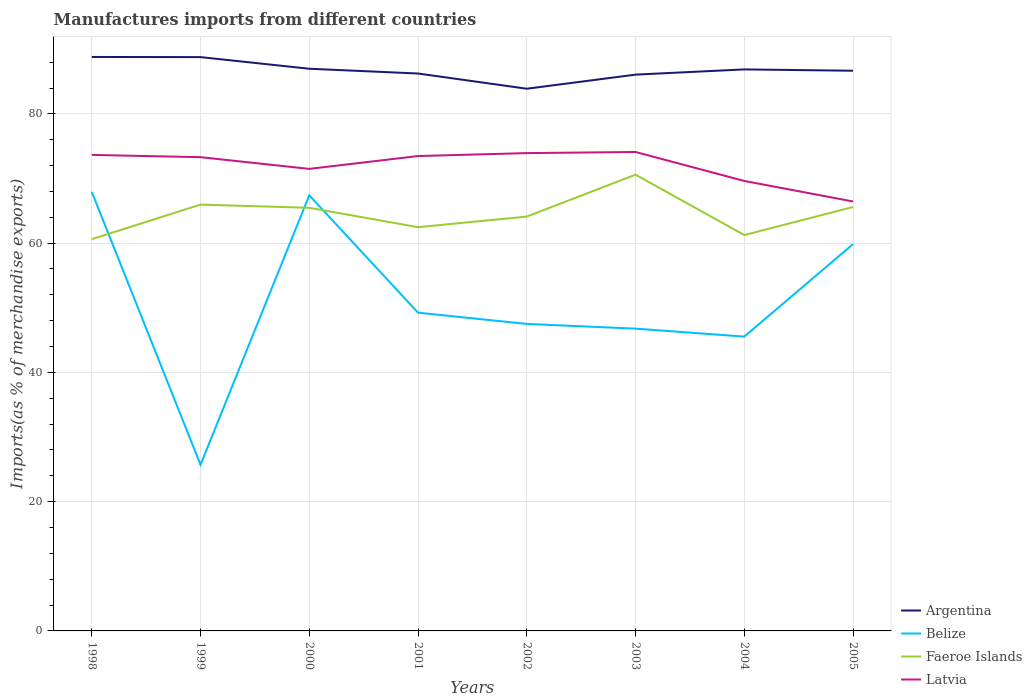How many different coloured lines are there?
Your answer should be very brief. 4. Does the line corresponding to Argentina intersect with the line corresponding to Faeroe Islands?
Your answer should be compact. No. Across all years, what is the maximum percentage of imports to different countries in Belize?
Offer a very short reply. 25.71. What is the total percentage of imports to different countries in Argentina in the graph?
Ensure brevity in your answer.  0.21. What is the difference between the highest and the second highest percentage of imports to different countries in Argentina?
Give a very brief answer. 4.91. What is the difference between the highest and the lowest percentage of imports to different countries in Faeroe Islands?
Your answer should be compact. 4. Is the percentage of imports to different countries in Faeroe Islands strictly greater than the percentage of imports to different countries in Belize over the years?
Your answer should be very brief. No. Does the graph contain any zero values?
Your answer should be very brief. No. Does the graph contain grids?
Make the answer very short. Yes. Where does the legend appear in the graph?
Provide a succinct answer. Bottom right. How many legend labels are there?
Keep it short and to the point. 4. What is the title of the graph?
Make the answer very short. Manufactures imports from different countries. What is the label or title of the X-axis?
Provide a succinct answer. Years. What is the label or title of the Y-axis?
Give a very brief answer. Imports(as % of merchandise exports). What is the Imports(as % of merchandise exports) in Argentina in 1998?
Keep it short and to the point. 88.81. What is the Imports(as % of merchandise exports) in Belize in 1998?
Offer a very short reply. 67.93. What is the Imports(as % of merchandise exports) of Faeroe Islands in 1998?
Your answer should be very brief. 60.61. What is the Imports(as % of merchandise exports) in Latvia in 1998?
Your answer should be compact. 73.65. What is the Imports(as % of merchandise exports) of Argentina in 1999?
Offer a terse response. 88.78. What is the Imports(as % of merchandise exports) of Belize in 1999?
Give a very brief answer. 25.71. What is the Imports(as % of merchandise exports) in Faeroe Islands in 1999?
Your answer should be very brief. 65.96. What is the Imports(as % of merchandise exports) of Latvia in 1999?
Make the answer very short. 73.3. What is the Imports(as % of merchandise exports) in Argentina in 2000?
Give a very brief answer. 86.98. What is the Imports(as % of merchandise exports) of Belize in 2000?
Keep it short and to the point. 67.4. What is the Imports(as % of merchandise exports) of Faeroe Islands in 2000?
Give a very brief answer. 65.47. What is the Imports(as % of merchandise exports) of Latvia in 2000?
Provide a short and direct response. 71.49. What is the Imports(as % of merchandise exports) in Argentina in 2001?
Offer a very short reply. 86.25. What is the Imports(as % of merchandise exports) in Belize in 2001?
Your response must be concise. 49.24. What is the Imports(as % of merchandise exports) in Faeroe Islands in 2001?
Your answer should be compact. 62.47. What is the Imports(as % of merchandise exports) of Latvia in 2001?
Your answer should be compact. 73.48. What is the Imports(as % of merchandise exports) of Argentina in 2002?
Your response must be concise. 83.89. What is the Imports(as % of merchandise exports) of Belize in 2002?
Ensure brevity in your answer.  47.5. What is the Imports(as % of merchandise exports) of Faeroe Islands in 2002?
Make the answer very short. 64.11. What is the Imports(as % of merchandise exports) of Latvia in 2002?
Provide a short and direct response. 73.93. What is the Imports(as % of merchandise exports) in Argentina in 2003?
Your answer should be very brief. 86.07. What is the Imports(as % of merchandise exports) in Belize in 2003?
Offer a very short reply. 46.77. What is the Imports(as % of merchandise exports) in Faeroe Islands in 2003?
Provide a succinct answer. 70.6. What is the Imports(as % of merchandise exports) in Latvia in 2003?
Offer a very short reply. 74.1. What is the Imports(as % of merchandise exports) of Argentina in 2004?
Provide a succinct answer. 86.88. What is the Imports(as % of merchandise exports) in Belize in 2004?
Make the answer very short. 45.54. What is the Imports(as % of merchandise exports) in Faeroe Islands in 2004?
Keep it short and to the point. 61.25. What is the Imports(as % of merchandise exports) in Latvia in 2004?
Offer a terse response. 69.62. What is the Imports(as % of merchandise exports) in Argentina in 2005?
Ensure brevity in your answer.  86.68. What is the Imports(as % of merchandise exports) of Belize in 2005?
Ensure brevity in your answer.  59.85. What is the Imports(as % of merchandise exports) of Faeroe Islands in 2005?
Ensure brevity in your answer.  65.59. What is the Imports(as % of merchandise exports) of Latvia in 2005?
Your answer should be compact. 66.45. Across all years, what is the maximum Imports(as % of merchandise exports) of Argentina?
Give a very brief answer. 88.81. Across all years, what is the maximum Imports(as % of merchandise exports) in Belize?
Make the answer very short. 67.93. Across all years, what is the maximum Imports(as % of merchandise exports) in Faeroe Islands?
Offer a very short reply. 70.6. Across all years, what is the maximum Imports(as % of merchandise exports) of Latvia?
Offer a very short reply. 74.1. Across all years, what is the minimum Imports(as % of merchandise exports) in Argentina?
Provide a succinct answer. 83.89. Across all years, what is the minimum Imports(as % of merchandise exports) in Belize?
Give a very brief answer. 25.71. Across all years, what is the minimum Imports(as % of merchandise exports) of Faeroe Islands?
Your response must be concise. 60.61. Across all years, what is the minimum Imports(as % of merchandise exports) of Latvia?
Give a very brief answer. 66.45. What is the total Imports(as % of merchandise exports) of Argentina in the graph?
Provide a succinct answer. 694.34. What is the total Imports(as % of merchandise exports) of Belize in the graph?
Ensure brevity in your answer.  409.94. What is the total Imports(as % of merchandise exports) in Faeroe Islands in the graph?
Offer a very short reply. 516.06. What is the total Imports(as % of merchandise exports) in Latvia in the graph?
Keep it short and to the point. 576.02. What is the difference between the Imports(as % of merchandise exports) of Argentina in 1998 and that in 1999?
Make the answer very short. 0.02. What is the difference between the Imports(as % of merchandise exports) of Belize in 1998 and that in 1999?
Your answer should be very brief. 42.21. What is the difference between the Imports(as % of merchandise exports) in Faeroe Islands in 1998 and that in 1999?
Offer a very short reply. -5.35. What is the difference between the Imports(as % of merchandise exports) in Latvia in 1998 and that in 1999?
Provide a short and direct response. 0.35. What is the difference between the Imports(as % of merchandise exports) in Argentina in 1998 and that in 2000?
Give a very brief answer. 1.82. What is the difference between the Imports(as % of merchandise exports) in Belize in 1998 and that in 2000?
Keep it short and to the point. 0.52. What is the difference between the Imports(as % of merchandise exports) of Faeroe Islands in 1998 and that in 2000?
Offer a very short reply. -4.86. What is the difference between the Imports(as % of merchandise exports) in Latvia in 1998 and that in 2000?
Give a very brief answer. 2.16. What is the difference between the Imports(as % of merchandise exports) in Argentina in 1998 and that in 2001?
Your answer should be very brief. 2.56. What is the difference between the Imports(as % of merchandise exports) in Belize in 1998 and that in 2001?
Your answer should be compact. 18.68. What is the difference between the Imports(as % of merchandise exports) of Faeroe Islands in 1998 and that in 2001?
Your response must be concise. -1.86. What is the difference between the Imports(as % of merchandise exports) in Latvia in 1998 and that in 2001?
Provide a succinct answer. 0.18. What is the difference between the Imports(as % of merchandise exports) of Argentina in 1998 and that in 2002?
Offer a very short reply. 4.91. What is the difference between the Imports(as % of merchandise exports) of Belize in 1998 and that in 2002?
Keep it short and to the point. 20.43. What is the difference between the Imports(as % of merchandise exports) in Faeroe Islands in 1998 and that in 2002?
Offer a very short reply. -3.5. What is the difference between the Imports(as % of merchandise exports) in Latvia in 1998 and that in 2002?
Your answer should be compact. -0.28. What is the difference between the Imports(as % of merchandise exports) in Argentina in 1998 and that in 2003?
Ensure brevity in your answer.  2.73. What is the difference between the Imports(as % of merchandise exports) of Belize in 1998 and that in 2003?
Keep it short and to the point. 21.16. What is the difference between the Imports(as % of merchandise exports) of Faeroe Islands in 1998 and that in 2003?
Your response must be concise. -9.98. What is the difference between the Imports(as % of merchandise exports) of Latvia in 1998 and that in 2003?
Make the answer very short. -0.45. What is the difference between the Imports(as % of merchandise exports) in Argentina in 1998 and that in 2004?
Offer a very short reply. 1.93. What is the difference between the Imports(as % of merchandise exports) of Belize in 1998 and that in 2004?
Offer a very short reply. 22.39. What is the difference between the Imports(as % of merchandise exports) in Faeroe Islands in 1998 and that in 2004?
Your response must be concise. -0.64. What is the difference between the Imports(as % of merchandise exports) of Latvia in 1998 and that in 2004?
Your answer should be very brief. 4.03. What is the difference between the Imports(as % of merchandise exports) of Argentina in 1998 and that in 2005?
Your answer should be compact. 2.13. What is the difference between the Imports(as % of merchandise exports) in Belize in 1998 and that in 2005?
Your response must be concise. 8.08. What is the difference between the Imports(as % of merchandise exports) in Faeroe Islands in 1998 and that in 2005?
Your answer should be compact. -4.98. What is the difference between the Imports(as % of merchandise exports) of Latvia in 1998 and that in 2005?
Make the answer very short. 7.21. What is the difference between the Imports(as % of merchandise exports) of Argentina in 1999 and that in 2000?
Offer a terse response. 1.8. What is the difference between the Imports(as % of merchandise exports) of Belize in 1999 and that in 2000?
Offer a terse response. -41.69. What is the difference between the Imports(as % of merchandise exports) in Faeroe Islands in 1999 and that in 2000?
Make the answer very short. 0.49. What is the difference between the Imports(as % of merchandise exports) in Latvia in 1999 and that in 2000?
Provide a succinct answer. 1.81. What is the difference between the Imports(as % of merchandise exports) in Argentina in 1999 and that in 2001?
Your response must be concise. 2.54. What is the difference between the Imports(as % of merchandise exports) of Belize in 1999 and that in 2001?
Your response must be concise. -23.53. What is the difference between the Imports(as % of merchandise exports) of Faeroe Islands in 1999 and that in 2001?
Provide a short and direct response. 3.49. What is the difference between the Imports(as % of merchandise exports) of Latvia in 1999 and that in 2001?
Offer a very short reply. -0.17. What is the difference between the Imports(as % of merchandise exports) in Argentina in 1999 and that in 2002?
Your answer should be compact. 4.89. What is the difference between the Imports(as % of merchandise exports) of Belize in 1999 and that in 2002?
Offer a terse response. -21.79. What is the difference between the Imports(as % of merchandise exports) in Faeroe Islands in 1999 and that in 2002?
Your answer should be very brief. 1.85. What is the difference between the Imports(as % of merchandise exports) of Latvia in 1999 and that in 2002?
Offer a very short reply. -0.63. What is the difference between the Imports(as % of merchandise exports) in Argentina in 1999 and that in 2003?
Provide a short and direct response. 2.71. What is the difference between the Imports(as % of merchandise exports) of Belize in 1999 and that in 2003?
Your answer should be compact. -21.06. What is the difference between the Imports(as % of merchandise exports) in Faeroe Islands in 1999 and that in 2003?
Ensure brevity in your answer.  -4.63. What is the difference between the Imports(as % of merchandise exports) in Latvia in 1999 and that in 2003?
Provide a short and direct response. -0.8. What is the difference between the Imports(as % of merchandise exports) of Argentina in 1999 and that in 2004?
Keep it short and to the point. 1.9. What is the difference between the Imports(as % of merchandise exports) in Belize in 1999 and that in 2004?
Ensure brevity in your answer.  -19.83. What is the difference between the Imports(as % of merchandise exports) of Faeroe Islands in 1999 and that in 2004?
Provide a short and direct response. 4.71. What is the difference between the Imports(as % of merchandise exports) of Latvia in 1999 and that in 2004?
Provide a short and direct response. 3.68. What is the difference between the Imports(as % of merchandise exports) in Argentina in 1999 and that in 2005?
Keep it short and to the point. 2.11. What is the difference between the Imports(as % of merchandise exports) of Belize in 1999 and that in 2005?
Your answer should be very brief. -34.13. What is the difference between the Imports(as % of merchandise exports) of Faeroe Islands in 1999 and that in 2005?
Make the answer very short. 0.37. What is the difference between the Imports(as % of merchandise exports) in Latvia in 1999 and that in 2005?
Your answer should be very brief. 6.86. What is the difference between the Imports(as % of merchandise exports) of Argentina in 2000 and that in 2001?
Keep it short and to the point. 0.74. What is the difference between the Imports(as % of merchandise exports) in Belize in 2000 and that in 2001?
Make the answer very short. 18.16. What is the difference between the Imports(as % of merchandise exports) of Faeroe Islands in 2000 and that in 2001?
Provide a short and direct response. 3. What is the difference between the Imports(as % of merchandise exports) of Latvia in 2000 and that in 2001?
Provide a succinct answer. -1.99. What is the difference between the Imports(as % of merchandise exports) of Argentina in 2000 and that in 2002?
Your answer should be very brief. 3.09. What is the difference between the Imports(as % of merchandise exports) in Belize in 2000 and that in 2002?
Your answer should be very brief. 19.9. What is the difference between the Imports(as % of merchandise exports) in Faeroe Islands in 2000 and that in 2002?
Make the answer very short. 1.36. What is the difference between the Imports(as % of merchandise exports) in Latvia in 2000 and that in 2002?
Offer a very short reply. -2.44. What is the difference between the Imports(as % of merchandise exports) in Argentina in 2000 and that in 2003?
Make the answer very short. 0.91. What is the difference between the Imports(as % of merchandise exports) of Belize in 2000 and that in 2003?
Your answer should be compact. 20.63. What is the difference between the Imports(as % of merchandise exports) in Faeroe Islands in 2000 and that in 2003?
Your response must be concise. -5.13. What is the difference between the Imports(as % of merchandise exports) in Latvia in 2000 and that in 2003?
Your answer should be compact. -2.61. What is the difference between the Imports(as % of merchandise exports) in Argentina in 2000 and that in 2004?
Your answer should be very brief. 0.1. What is the difference between the Imports(as % of merchandise exports) of Belize in 2000 and that in 2004?
Make the answer very short. 21.86. What is the difference between the Imports(as % of merchandise exports) of Faeroe Islands in 2000 and that in 2004?
Your answer should be very brief. 4.22. What is the difference between the Imports(as % of merchandise exports) in Latvia in 2000 and that in 2004?
Your answer should be very brief. 1.87. What is the difference between the Imports(as % of merchandise exports) in Argentina in 2000 and that in 2005?
Your answer should be very brief. 0.31. What is the difference between the Imports(as % of merchandise exports) in Belize in 2000 and that in 2005?
Keep it short and to the point. 7.56. What is the difference between the Imports(as % of merchandise exports) of Faeroe Islands in 2000 and that in 2005?
Make the answer very short. -0.12. What is the difference between the Imports(as % of merchandise exports) in Latvia in 2000 and that in 2005?
Offer a terse response. 5.04. What is the difference between the Imports(as % of merchandise exports) of Argentina in 2001 and that in 2002?
Your answer should be compact. 2.35. What is the difference between the Imports(as % of merchandise exports) of Belize in 2001 and that in 2002?
Your response must be concise. 1.74. What is the difference between the Imports(as % of merchandise exports) in Faeroe Islands in 2001 and that in 2002?
Offer a very short reply. -1.64. What is the difference between the Imports(as % of merchandise exports) in Latvia in 2001 and that in 2002?
Give a very brief answer. -0.46. What is the difference between the Imports(as % of merchandise exports) of Argentina in 2001 and that in 2003?
Your response must be concise. 0.17. What is the difference between the Imports(as % of merchandise exports) in Belize in 2001 and that in 2003?
Provide a succinct answer. 2.47. What is the difference between the Imports(as % of merchandise exports) in Faeroe Islands in 2001 and that in 2003?
Your response must be concise. -8.13. What is the difference between the Imports(as % of merchandise exports) in Latvia in 2001 and that in 2003?
Give a very brief answer. -0.63. What is the difference between the Imports(as % of merchandise exports) of Argentina in 2001 and that in 2004?
Ensure brevity in your answer.  -0.64. What is the difference between the Imports(as % of merchandise exports) of Belize in 2001 and that in 2004?
Offer a very short reply. 3.71. What is the difference between the Imports(as % of merchandise exports) of Faeroe Islands in 2001 and that in 2004?
Provide a succinct answer. 1.22. What is the difference between the Imports(as % of merchandise exports) in Latvia in 2001 and that in 2004?
Ensure brevity in your answer.  3.85. What is the difference between the Imports(as % of merchandise exports) of Argentina in 2001 and that in 2005?
Ensure brevity in your answer.  -0.43. What is the difference between the Imports(as % of merchandise exports) in Belize in 2001 and that in 2005?
Offer a very short reply. -10.6. What is the difference between the Imports(as % of merchandise exports) in Faeroe Islands in 2001 and that in 2005?
Provide a short and direct response. -3.12. What is the difference between the Imports(as % of merchandise exports) of Latvia in 2001 and that in 2005?
Give a very brief answer. 7.03. What is the difference between the Imports(as % of merchandise exports) of Argentina in 2002 and that in 2003?
Make the answer very short. -2.18. What is the difference between the Imports(as % of merchandise exports) in Belize in 2002 and that in 2003?
Provide a short and direct response. 0.73. What is the difference between the Imports(as % of merchandise exports) in Faeroe Islands in 2002 and that in 2003?
Your answer should be very brief. -6.49. What is the difference between the Imports(as % of merchandise exports) in Latvia in 2002 and that in 2003?
Keep it short and to the point. -0.17. What is the difference between the Imports(as % of merchandise exports) in Argentina in 2002 and that in 2004?
Your response must be concise. -2.99. What is the difference between the Imports(as % of merchandise exports) of Belize in 2002 and that in 2004?
Make the answer very short. 1.96. What is the difference between the Imports(as % of merchandise exports) in Faeroe Islands in 2002 and that in 2004?
Provide a short and direct response. 2.86. What is the difference between the Imports(as % of merchandise exports) of Latvia in 2002 and that in 2004?
Offer a terse response. 4.31. What is the difference between the Imports(as % of merchandise exports) of Argentina in 2002 and that in 2005?
Your answer should be compact. -2.78. What is the difference between the Imports(as % of merchandise exports) of Belize in 2002 and that in 2005?
Keep it short and to the point. -12.34. What is the difference between the Imports(as % of merchandise exports) of Faeroe Islands in 2002 and that in 2005?
Ensure brevity in your answer.  -1.48. What is the difference between the Imports(as % of merchandise exports) of Latvia in 2002 and that in 2005?
Ensure brevity in your answer.  7.49. What is the difference between the Imports(as % of merchandise exports) in Argentina in 2003 and that in 2004?
Offer a very short reply. -0.81. What is the difference between the Imports(as % of merchandise exports) of Belize in 2003 and that in 2004?
Provide a succinct answer. 1.23. What is the difference between the Imports(as % of merchandise exports) in Faeroe Islands in 2003 and that in 2004?
Ensure brevity in your answer.  9.34. What is the difference between the Imports(as % of merchandise exports) in Latvia in 2003 and that in 2004?
Your answer should be very brief. 4.48. What is the difference between the Imports(as % of merchandise exports) in Argentina in 2003 and that in 2005?
Keep it short and to the point. -0.6. What is the difference between the Imports(as % of merchandise exports) in Belize in 2003 and that in 2005?
Offer a terse response. -13.07. What is the difference between the Imports(as % of merchandise exports) of Faeroe Islands in 2003 and that in 2005?
Your response must be concise. 5.01. What is the difference between the Imports(as % of merchandise exports) in Latvia in 2003 and that in 2005?
Make the answer very short. 7.66. What is the difference between the Imports(as % of merchandise exports) in Argentina in 2004 and that in 2005?
Provide a succinct answer. 0.21. What is the difference between the Imports(as % of merchandise exports) of Belize in 2004 and that in 2005?
Keep it short and to the point. -14.31. What is the difference between the Imports(as % of merchandise exports) in Faeroe Islands in 2004 and that in 2005?
Provide a succinct answer. -4.34. What is the difference between the Imports(as % of merchandise exports) in Latvia in 2004 and that in 2005?
Keep it short and to the point. 3.18. What is the difference between the Imports(as % of merchandise exports) in Argentina in 1998 and the Imports(as % of merchandise exports) in Belize in 1999?
Provide a short and direct response. 63.09. What is the difference between the Imports(as % of merchandise exports) in Argentina in 1998 and the Imports(as % of merchandise exports) in Faeroe Islands in 1999?
Give a very brief answer. 22.84. What is the difference between the Imports(as % of merchandise exports) of Argentina in 1998 and the Imports(as % of merchandise exports) of Latvia in 1999?
Give a very brief answer. 15.5. What is the difference between the Imports(as % of merchandise exports) in Belize in 1998 and the Imports(as % of merchandise exports) in Faeroe Islands in 1999?
Your answer should be compact. 1.96. What is the difference between the Imports(as % of merchandise exports) of Belize in 1998 and the Imports(as % of merchandise exports) of Latvia in 1999?
Your answer should be very brief. -5.37. What is the difference between the Imports(as % of merchandise exports) in Faeroe Islands in 1998 and the Imports(as % of merchandise exports) in Latvia in 1999?
Provide a succinct answer. -12.69. What is the difference between the Imports(as % of merchandise exports) of Argentina in 1998 and the Imports(as % of merchandise exports) of Belize in 2000?
Make the answer very short. 21.4. What is the difference between the Imports(as % of merchandise exports) of Argentina in 1998 and the Imports(as % of merchandise exports) of Faeroe Islands in 2000?
Ensure brevity in your answer.  23.34. What is the difference between the Imports(as % of merchandise exports) in Argentina in 1998 and the Imports(as % of merchandise exports) in Latvia in 2000?
Your answer should be very brief. 17.32. What is the difference between the Imports(as % of merchandise exports) of Belize in 1998 and the Imports(as % of merchandise exports) of Faeroe Islands in 2000?
Your response must be concise. 2.46. What is the difference between the Imports(as % of merchandise exports) of Belize in 1998 and the Imports(as % of merchandise exports) of Latvia in 2000?
Keep it short and to the point. -3.56. What is the difference between the Imports(as % of merchandise exports) in Faeroe Islands in 1998 and the Imports(as % of merchandise exports) in Latvia in 2000?
Ensure brevity in your answer.  -10.88. What is the difference between the Imports(as % of merchandise exports) of Argentina in 1998 and the Imports(as % of merchandise exports) of Belize in 2001?
Provide a short and direct response. 39.56. What is the difference between the Imports(as % of merchandise exports) in Argentina in 1998 and the Imports(as % of merchandise exports) in Faeroe Islands in 2001?
Make the answer very short. 26.34. What is the difference between the Imports(as % of merchandise exports) of Argentina in 1998 and the Imports(as % of merchandise exports) of Latvia in 2001?
Provide a short and direct response. 15.33. What is the difference between the Imports(as % of merchandise exports) in Belize in 1998 and the Imports(as % of merchandise exports) in Faeroe Islands in 2001?
Make the answer very short. 5.46. What is the difference between the Imports(as % of merchandise exports) of Belize in 1998 and the Imports(as % of merchandise exports) of Latvia in 2001?
Your response must be concise. -5.55. What is the difference between the Imports(as % of merchandise exports) of Faeroe Islands in 1998 and the Imports(as % of merchandise exports) of Latvia in 2001?
Provide a short and direct response. -12.86. What is the difference between the Imports(as % of merchandise exports) in Argentina in 1998 and the Imports(as % of merchandise exports) in Belize in 2002?
Offer a terse response. 41.31. What is the difference between the Imports(as % of merchandise exports) in Argentina in 1998 and the Imports(as % of merchandise exports) in Faeroe Islands in 2002?
Give a very brief answer. 24.7. What is the difference between the Imports(as % of merchandise exports) of Argentina in 1998 and the Imports(as % of merchandise exports) of Latvia in 2002?
Give a very brief answer. 14.87. What is the difference between the Imports(as % of merchandise exports) in Belize in 1998 and the Imports(as % of merchandise exports) in Faeroe Islands in 2002?
Offer a very short reply. 3.82. What is the difference between the Imports(as % of merchandise exports) of Belize in 1998 and the Imports(as % of merchandise exports) of Latvia in 2002?
Your answer should be compact. -6. What is the difference between the Imports(as % of merchandise exports) of Faeroe Islands in 1998 and the Imports(as % of merchandise exports) of Latvia in 2002?
Keep it short and to the point. -13.32. What is the difference between the Imports(as % of merchandise exports) in Argentina in 1998 and the Imports(as % of merchandise exports) in Belize in 2003?
Offer a very short reply. 42.04. What is the difference between the Imports(as % of merchandise exports) in Argentina in 1998 and the Imports(as % of merchandise exports) in Faeroe Islands in 2003?
Offer a terse response. 18.21. What is the difference between the Imports(as % of merchandise exports) of Argentina in 1998 and the Imports(as % of merchandise exports) of Latvia in 2003?
Provide a short and direct response. 14.7. What is the difference between the Imports(as % of merchandise exports) in Belize in 1998 and the Imports(as % of merchandise exports) in Faeroe Islands in 2003?
Your answer should be very brief. -2.67. What is the difference between the Imports(as % of merchandise exports) in Belize in 1998 and the Imports(as % of merchandise exports) in Latvia in 2003?
Ensure brevity in your answer.  -6.18. What is the difference between the Imports(as % of merchandise exports) of Faeroe Islands in 1998 and the Imports(as % of merchandise exports) of Latvia in 2003?
Provide a succinct answer. -13.49. What is the difference between the Imports(as % of merchandise exports) of Argentina in 1998 and the Imports(as % of merchandise exports) of Belize in 2004?
Keep it short and to the point. 43.27. What is the difference between the Imports(as % of merchandise exports) of Argentina in 1998 and the Imports(as % of merchandise exports) of Faeroe Islands in 2004?
Keep it short and to the point. 27.55. What is the difference between the Imports(as % of merchandise exports) of Argentina in 1998 and the Imports(as % of merchandise exports) of Latvia in 2004?
Ensure brevity in your answer.  19.18. What is the difference between the Imports(as % of merchandise exports) of Belize in 1998 and the Imports(as % of merchandise exports) of Faeroe Islands in 2004?
Offer a very short reply. 6.67. What is the difference between the Imports(as % of merchandise exports) in Belize in 1998 and the Imports(as % of merchandise exports) in Latvia in 2004?
Give a very brief answer. -1.69. What is the difference between the Imports(as % of merchandise exports) of Faeroe Islands in 1998 and the Imports(as % of merchandise exports) of Latvia in 2004?
Your response must be concise. -9.01. What is the difference between the Imports(as % of merchandise exports) in Argentina in 1998 and the Imports(as % of merchandise exports) in Belize in 2005?
Offer a terse response. 28.96. What is the difference between the Imports(as % of merchandise exports) of Argentina in 1998 and the Imports(as % of merchandise exports) of Faeroe Islands in 2005?
Provide a short and direct response. 23.22. What is the difference between the Imports(as % of merchandise exports) in Argentina in 1998 and the Imports(as % of merchandise exports) in Latvia in 2005?
Keep it short and to the point. 22.36. What is the difference between the Imports(as % of merchandise exports) of Belize in 1998 and the Imports(as % of merchandise exports) of Faeroe Islands in 2005?
Your response must be concise. 2.34. What is the difference between the Imports(as % of merchandise exports) in Belize in 1998 and the Imports(as % of merchandise exports) in Latvia in 2005?
Your response must be concise. 1.48. What is the difference between the Imports(as % of merchandise exports) of Faeroe Islands in 1998 and the Imports(as % of merchandise exports) of Latvia in 2005?
Your response must be concise. -5.83. What is the difference between the Imports(as % of merchandise exports) of Argentina in 1999 and the Imports(as % of merchandise exports) of Belize in 2000?
Your answer should be very brief. 21.38. What is the difference between the Imports(as % of merchandise exports) in Argentina in 1999 and the Imports(as % of merchandise exports) in Faeroe Islands in 2000?
Your answer should be compact. 23.32. What is the difference between the Imports(as % of merchandise exports) in Argentina in 1999 and the Imports(as % of merchandise exports) in Latvia in 2000?
Provide a succinct answer. 17.29. What is the difference between the Imports(as % of merchandise exports) in Belize in 1999 and the Imports(as % of merchandise exports) in Faeroe Islands in 2000?
Provide a succinct answer. -39.76. What is the difference between the Imports(as % of merchandise exports) of Belize in 1999 and the Imports(as % of merchandise exports) of Latvia in 2000?
Your answer should be very brief. -45.78. What is the difference between the Imports(as % of merchandise exports) of Faeroe Islands in 1999 and the Imports(as % of merchandise exports) of Latvia in 2000?
Give a very brief answer. -5.53. What is the difference between the Imports(as % of merchandise exports) in Argentina in 1999 and the Imports(as % of merchandise exports) in Belize in 2001?
Keep it short and to the point. 39.54. What is the difference between the Imports(as % of merchandise exports) in Argentina in 1999 and the Imports(as % of merchandise exports) in Faeroe Islands in 2001?
Ensure brevity in your answer.  26.32. What is the difference between the Imports(as % of merchandise exports) in Argentina in 1999 and the Imports(as % of merchandise exports) in Latvia in 2001?
Ensure brevity in your answer.  15.31. What is the difference between the Imports(as % of merchandise exports) of Belize in 1999 and the Imports(as % of merchandise exports) of Faeroe Islands in 2001?
Make the answer very short. -36.76. What is the difference between the Imports(as % of merchandise exports) in Belize in 1999 and the Imports(as % of merchandise exports) in Latvia in 2001?
Offer a terse response. -47.76. What is the difference between the Imports(as % of merchandise exports) of Faeroe Islands in 1999 and the Imports(as % of merchandise exports) of Latvia in 2001?
Your answer should be compact. -7.51. What is the difference between the Imports(as % of merchandise exports) of Argentina in 1999 and the Imports(as % of merchandise exports) of Belize in 2002?
Provide a short and direct response. 41.28. What is the difference between the Imports(as % of merchandise exports) of Argentina in 1999 and the Imports(as % of merchandise exports) of Faeroe Islands in 2002?
Make the answer very short. 24.67. What is the difference between the Imports(as % of merchandise exports) in Argentina in 1999 and the Imports(as % of merchandise exports) in Latvia in 2002?
Give a very brief answer. 14.85. What is the difference between the Imports(as % of merchandise exports) of Belize in 1999 and the Imports(as % of merchandise exports) of Faeroe Islands in 2002?
Ensure brevity in your answer.  -38.4. What is the difference between the Imports(as % of merchandise exports) of Belize in 1999 and the Imports(as % of merchandise exports) of Latvia in 2002?
Ensure brevity in your answer.  -48.22. What is the difference between the Imports(as % of merchandise exports) of Faeroe Islands in 1999 and the Imports(as % of merchandise exports) of Latvia in 2002?
Give a very brief answer. -7.97. What is the difference between the Imports(as % of merchandise exports) of Argentina in 1999 and the Imports(as % of merchandise exports) of Belize in 2003?
Make the answer very short. 42.01. What is the difference between the Imports(as % of merchandise exports) in Argentina in 1999 and the Imports(as % of merchandise exports) in Faeroe Islands in 2003?
Offer a very short reply. 18.19. What is the difference between the Imports(as % of merchandise exports) in Argentina in 1999 and the Imports(as % of merchandise exports) in Latvia in 2003?
Your response must be concise. 14.68. What is the difference between the Imports(as % of merchandise exports) of Belize in 1999 and the Imports(as % of merchandise exports) of Faeroe Islands in 2003?
Make the answer very short. -44.88. What is the difference between the Imports(as % of merchandise exports) of Belize in 1999 and the Imports(as % of merchandise exports) of Latvia in 2003?
Provide a succinct answer. -48.39. What is the difference between the Imports(as % of merchandise exports) in Faeroe Islands in 1999 and the Imports(as % of merchandise exports) in Latvia in 2003?
Provide a short and direct response. -8.14. What is the difference between the Imports(as % of merchandise exports) of Argentina in 1999 and the Imports(as % of merchandise exports) of Belize in 2004?
Provide a short and direct response. 43.25. What is the difference between the Imports(as % of merchandise exports) of Argentina in 1999 and the Imports(as % of merchandise exports) of Faeroe Islands in 2004?
Your response must be concise. 27.53. What is the difference between the Imports(as % of merchandise exports) of Argentina in 1999 and the Imports(as % of merchandise exports) of Latvia in 2004?
Provide a succinct answer. 19.16. What is the difference between the Imports(as % of merchandise exports) in Belize in 1999 and the Imports(as % of merchandise exports) in Faeroe Islands in 2004?
Ensure brevity in your answer.  -35.54. What is the difference between the Imports(as % of merchandise exports) in Belize in 1999 and the Imports(as % of merchandise exports) in Latvia in 2004?
Provide a succinct answer. -43.91. What is the difference between the Imports(as % of merchandise exports) of Faeroe Islands in 1999 and the Imports(as % of merchandise exports) of Latvia in 2004?
Ensure brevity in your answer.  -3.66. What is the difference between the Imports(as % of merchandise exports) of Argentina in 1999 and the Imports(as % of merchandise exports) of Belize in 2005?
Keep it short and to the point. 28.94. What is the difference between the Imports(as % of merchandise exports) in Argentina in 1999 and the Imports(as % of merchandise exports) in Faeroe Islands in 2005?
Keep it short and to the point. 23.19. What is the difference between the Imports(as % of merchandise exports) of Argentina in 1999 and the Imports(as % of merchandise exports) of Latvia in 2005?
Your answer should be very brief. 22.34. What is the difference between the Imports(as % of merchandise exports) of Belize in 1999 and the Imports(as % of merchandise exports) of Faeroe Islands in 2005?
Your response must be concise. -39.88. What is the difference between the Imports(as % of merchandise exports) in Belize in 1999 and the Imports(as % of merchandise exports) in Latvia in 2005?
Keep it short and to the point. -40.73. What is the difference between the Imports(as % of merchandise exports) in Faeroe Islands in 1999 and the Imports(as % of merchandise exports) in Latvia in 2005?
Your answer should be compact. -0.48. What is the difference between the Imports(as % of merchandise exports) in Argentina in 2000 and the Imports(as % of merchandise exports) in Belize in 2001?
Offer a very short reply. 37.74. What is the difference between the Imports(as % of merchandise exports) of Argentina in 2000 and the Imports(as % of merchandise exports) of Faeroe Islands in 2001?
Your answer should be compact. 24.51. What is the difference between the Imports(as % of merchandise exports) of Argentina in 2000 and the Imports(as % of merchandise exports) of Latvia in 2001?
Your answer should be very brief. 13.51. What is the difference between the Imports(as % of merchandise exports) in Belize in 2000 and the Imports(as % of merchandise exports) in Faeroe Islands in 2001?
Give a very brief answer. 4.93. What is the difference between the Imports(as % of merchandise exports) in Belize in 2000 and the Imports(as % of merchandise exports) in Latvia in 2001?
Your response must be concise. -6.07. What is the difference between the Imports(as % of merchandise exports) of Faeroe Islands in 2000 and the Imports(as % of merchandise exports) of Latvia in 2001?
Make the answer very short. -8.01. What is the difference between the Imports(as % of merchandise exports) in Argentina in 2000 and the Imports(as % of merchandise exports) in Belize in 2002?
Keep it short and to the point. 39.48. What is the difference between the Imports(as % of merchandise exports) of Argentina in 2000 and the Imports(as % of merchandise exports) of Faeroe Islands in 2002?
Your answer should be compact. 22.87. What is the difference between the Imports(as % of merchandise exports) of Argentina in 2000 and the Imports(as % of merchandise exports) of Latvia in 2002?
Give a very brief answer. 13.05. What is the difference between the Imports(as % of merchandise exports) of Belize in 2000 and the Imports(as % of merchandise exports) of Faeroe Islands in 2002?
Ensure brevity in your answer.  3.29. What is the difference between the Imports(as % of merchandise exports) in Belize in 2000 and the Imports(as % of merchandise exports) in Latvia in 2002?
Provide a short and direct response. -6.53. What is the difference between the Imports(as % of merchandise exports) of Faeroe Islands in 2000 and the Imports(as % of merchandise exports) of Latvia in 2002?
Give a very brief answer. -8.46. What is the difference between the Imports(as % of merchandise exports) of Argentina in 2000 and the Imports(as % of merchandise exports) of Belize in 2003?
Your answer should be compact. 40.21. What is the difference between the Imports(as % of merchandise exports) of Argentina in 2000 and the Imports(as % of merchandise exports) of Faeroe Islands in 2003?
Make the answer very short. 16.39. What is the difference between the Imports(as % of merchandise exports) in Argentina in 2000 and the Imports(as % of merchandise exports) in Latvia in 2003?
Make the answer very short. 12.88. What is the difference between the Imports(as % of merchandise exports) in Belize in 2000 and the Imports(as % of merchandise exports) in Faeroe Islands in 2003?
Your answer should be very brief. -3.19. What is the difference between the Imports(as % of merchandise exports) in Belize in 2000 and the Imports(as % of merchandise exports) in Latvia in 2003?
Your answer should be very brief. -6.7. What is the difference between the Imports(as % of merchandise exports) of Faeroe Islands in 2000 and the Imports(as % of merchandise exports) of Latvia in 2003?
Keep it short and to the point. -8.63. What is the difference between the Imports(as % of merchandise exports) of Argentina in 2000 and the Imports(as % of merchandise exports) of Belize in 2004?
Your response must be concise. 41.45. What is the difference between the Imports(as % of merchandise exports) in Argentina in 2000 and the Imports(as % of merchandise exports) in Faeroe Islands in 2004?
Your answer should be very brief. 25.73. What is the difference between the Imports(as % of merchandise exports) in Argentina in 2000 and the Imports(as % of merchandise exports) in Latvia in 2004?
Provide a short and direct response. 17.36. What is the difference between the Imports(as % of merchandise exports) in Belize in 2000 and the Imports(as % of merchandise exports) in Faeroe Islands in 2004?
Offer a very short reply. 6.15. What is the difference between the Imports(as % of merchandise exports) in Belize in 2000 and the Imports(as % of merchandise exports) in Latvia in 2004?
Your answer should be very brief. -2.22. What is the difference between the Imports(as % of merchandise exports) in Faeroe Islands in 2000 and the Imports(as % of merchandise exports) in Latvia in 2004?
Your answer should be compact. -4.15. What is the difference between the Imports(as % of merchandise exports) of Argentina in 2000 and the Imports(as % of merchandise exports) of Belize in 2005?
Offer a terse response. 27.14. What is the difference between the Imports(as % of merchandise exports) in Argentina in 2000 and the Imports(as % of merchandise exports) in Faeroe Islands in 2005?
Give a very brief answer. 21.39. What is the difference between the Imports(as % of merchandise exports) of Argentina in 2000 and the Imports(as % of merchandise exports) of Latvia in 2005?
Offer a very short reply. 20.54. What is the difference between the Imports(as % of merchandise exports) of Belize in 2000 and the Imports(as % of merchandise exports) of Faeroe Islands in 2005?
Provide a short and direct response. 1.81. What is the difference between the Imports(as % of merchandise exports) in Belize in 2000 and the Imports(as % of merchandise exports) in Latvia in 2005?
Your answer should be compact. 0.96. What is the difference between the Imports(as % of merchandise exports) of Faeroe Islands in 2000 and the Imports(as % of merchandise exports) of Latvia in 2005?
Your answer should be compact. -0.98. What is the difference between the Imports(as % of merchandise exports) of Argentina in 2001 and the Imports(as % of merchandise exports) of Belize in 2002?
Give a very brief answer. 38.74. What is the difference between the Imports(as % of merchandise exports) in Argentina in 2001 and the Imports(as % of merchandise exports) in Faeroe Islands in 2002?
Provide a short and direct response. 22.14. What is the difference between the Imports(as % of merchandise exports) in Argentina in 2001 and the Imports(as % of merchandise exports) in Latvia in 2002?
Your answer should be compact. 12.31. What is the difference between the Imports(as % of merchandise exports) of Belize in 2001 and the Imports(as % of merchandise exports) of Faeroe Islands in 2002?
Ensure brevity in your answer.  -14.87. What is the difference between the Imports(as % of merchandise exports) in Belize in 2001 and the Imports(as % of merchandise exports) in Latvia in 2002?
Provide a short and direct response. -24.69. What is the difference between the Imports(as % of merchandise exports) in Faeroe Islands in 2001 and the Imports(as % of merchandise exports) in Latvia in 2002?
Give a very brief answer. -11.46. What is the difference between the Imports(as % of merchandise exports) in Argentina in 2001 and the Imports(as % of merchandise exports) in Belize in 2003?
Your response must be concise. 39.48. What is the difference between the Imports(as % of merchandise exports) in Argentina in 2001 and the Imports(as % of merchandise exports) in Faeroe Islands in 2003?
Your answer should be very brief. 15.65. What is the difference between the Imports(as % of merchandise exports) of Argentina in 2001 and the Imports(as % of merchandise exports) of Latvia in 2003?
Give a very brief answer. 12.14. What is the difference between the Imports(as % of merchandise exports) in Belize in 2001 and the Imports(as % of merchandise exports) in Faeroe Islands in 2003?
Give a very brief answer. -21.35. What is the difference between the Imports(as % of merchandise exports) in Belize in 2001 and the Imports(as % of merchandise exports) in Latvia in 2003?
Your answer should be very brief. -24.86. What is the difference between the Imports(as % of merchandise exports) in Faeroe Islands in 2001 and the Imports(as % of merchandise exports) in Latvia in 2003?
Keep it short and to the point. -11.64. What is the difference between the Imports(as % of merchandise exports) in Argentina in 2001 and the Imports(as % of merchandise exports) in Belize in 2004?
Make the answer very short. 40.71. What is the difference between the Imports(as % of merchandise exports) in Argentina in 2001 and the Imports(as % of merchandise exports) in Faeroe Islands in 2004?
Provide a short and direct response. 24.99. What is the difference between the Imports(as % of merchandise exports) in Argentina in 2001 and the Imports(as % of merchandise exports) in Latvia in 2004?
Provide a short and direct response. 16.62. What is the difference between the Imports(as % of merchandise exports) in Belize in 2001 and the Imports(as % of merchandise exports) in Faeroe Islands in 2004?
Give a very brief answer. -12.01. What is the difference between the Imports(as % of merchandise exports) of Belize in 2001 and the Imports(as % of merchandise exports) of Latvia in 2004?
Provide a short and direct response. -20.38. What is the difference between the Imports(as % of merchandise exports) in Faeroe Islands in 2001 and the Imports(as % of merchandise exports) in Latvia in 2004?
Keep it short and to the point. -7.15. What is the difference between the Imports(as % of merchandise exports) of Argentina in 2001 and the Imports(as % of merchandise exports) of Belize in 2005?
Keep it short and to the point. 26.4. What is the difference between the Imports(as % of merchandise exports) of Argentina in 2001 and the Imports(as % of merchandise exports) of Faeroe Islands in 2005?
Your answer should be very brief. 20.66. What is the difference between the Imports(as % of merchandise exports) in Argentina in 2001 and the Imports(as % of merchandise exports) in Latvia in 2005?
Give a very brief answer. 19.8. What is the difference between the Imports(as % of merchandise exports) in Belize in 2001 and the Imports(as % of merchandise exports) in Faeroe Islands in 2005?
Provide a succinct answer. -16.35. What is the difference between the Imports(as % of merchandise exports) in Belize in 2001 and the Imports(as % of merchandise exports) in Latvia in 2005?
Make the answer very short. -17.2. What is the difference between the Imports(as % of merchandise exports) in Faeroe Islands in 2001 and the Imports(as % of merchandise exports) in Latvia in 2005?
Offer a very short reply. -3.98. What is the difference between the Imports(as % of merchandise exports) of Argentina in 2002 and the Imports(as % of merchandise exports) of Belize in 2003?
Offer a terse response. 37.12. What is the difference between the Imports(as % of merchandise exports) in Argentina in 2002 and the Imports(as % of merchandise exports) in Faeroe Islands in 2003?
Keep it short and to the point. 13.3. What is the difference between the Imports(as % of merchandise exports) of Argentina in 2002 and the Imports(as % of merchandise exports) of Latvia in 2003?
Offer a very short reply. 9.79. What is the difference between the Imports(as % of merchandise exports) in Belize in 2002 and the Imports(as % of merchandise exports) in Faeroe Islands in 2003?
Make the answer very short. -23.09. What is the difference between the Imports(as % of merchandise exports) of Belize in 2002 and the Imports(as % of merchandise exports) of Latvia in 2003?
Provide a short and direct response. -26.6. What is the difference between the Imports(as % of merchandise exports) in Faeroe Islands in 2002 and the Imports(as % of merchandise exports) in Latvia in 2003?
Ensure brevity in your answer.  -9.99. What is the difference between the Imports(as % of merchandise exports) of Argentina in 2002 and the Imports(as % of merchandise exports) of Belize in 2004?
Your answer should be compact. 38.35. What is the difference between the Imports(as % of merchandise exports) of Argentina in 2002 and the Imports(as % of merchandise exports) of Faeroe Islands in 2004?
Offer a terse response. 22.64. What is the difference between the Imports(as % of merchandise exports) in Argentina in 2002 and the Imports(as % of merchandise exports) in Latvia in 2004?
Ensure brevity in your answer.  14.27. What is the difference between the Imports(as % of merchandise exports) of Belize in 2002 and the Imports(as % of merchandise exports) of Faeroe Islands in 2004?
Give a very brief answer. -13.75. What is the difference between the Imports(as % of merchandise exports) in Belize in 2002 and the Imports(as % of merchandise exports) in Latvia in 2004?
Offer a terse response. -22.12. What is the difference between the Imports(as % of merchandise exports) in Faeroe Islands in 2002 and the Imports(as % of merchandise exports) in Latvia in 2004?
Keep it short and to the point. -5.51. What is the difference between the Imports(as % of merchandise exports) of Argentina in 2002 and the Imports(as % of merchandise exports) of Belize in 2005?
Your answer should be compact. 24.05. What is the difference between the Imports(as % of merchandise exports) in Argentina in 2002 and the Imports(as % of merchandise exports) in Faeroe Islands in 2005?
Provide a short and direct response. 18.3. What is the difference between the Imports(as % of merchandise exports) of Argentina in 2002 and the Imports(as % of merchandise exports) of Latvia in 2005?
Your answer should be very brief. 17.45. What is the difference between the Imports(as % of merchandise exports) in Belize in 2002 and the Imports(as % of merchandise exports) in Faeroe Islands in 2005?
Provide a short and direct response. -18.09. What is the difference between the Imports(as % of merchandise exports) in Belize in 2002 and the Imports(as % of merchandise exports) in Latvia in 2005?
Provide a short and direct response. -18.94. What is the difference between the Imports(as % of merchandise exports) in Faeroe Islands in 2002 and the Imports(as % of merchandise exports) in Latvia in 2005?
Offer a terse response. -2.34. What is the difference between the Imports(as % of merchandise exports) of Argentina in 2003 and the Imports(as % of merchandise exports) of Belize in 2004?
Give a very brief answer. 40.54. What is the difference between the Imports(as % of merchandise exports) of Argentina in 2003 and the Imports(as % of merchandise exports) of Faeroe Islands in 2004?
Keep it short and to the point. 24.82. What is the difference between the Imports(as % of merchandise exports) in Argentina in 2003 and the Imports(as % of merchandise exports) in Latvia in 2004?
Give a very brief answer. 16.45. What is the difference between the Imports(as % of merchandise exports) in Belize in 2003 and the Imports(as % of merchandise exports) in Faeroe Islands in 2004?
Your answer should be very brief. -14.48. What is the difference between the Imports(as % of merchandise exports) in Belize in 2003 and the Imports(as % of merchandise exports) in Latvia in 2004?
Provide a short and direct response. -22.85. What is the difference between the Imports(as % of merchandise exports) of Faeroe Islands in 2003 and the Imports(as % of merchandise exports) of Latvia in 2004?
Offer a terse response. 0.97. What is the difference between the Imports(as % of merchandise exports) in Argentina in 2003 and the Imports(as % of merchandise exports) in Belize in 2005?
Provide a short and direct response. 26.23. What is the difference between the Imports(as % of merchandise exports) in Argentina in 2003 and the Imports(as % of merchandise exports) in Faeroe Islands in 2005?
Make the answer very short. 20.48. What is the difference between the Imports(as % of merchandise exports) in Argentina in 2003 and the Imports(as % of merchandise exports) in Latvia in 2005?
Make the answer very short. 19.63. What is the difference between the Imports(as % of merchandise exports) in Belize in 2003 and the Imports(as % of merchandise exports) in Faeroe Islands in 2005?
Your answer should be very brief. -18.82. What is the difference between the Imports(as % of merchandise exports) of Belize in 2003 and the Imports(as % of merchandise exports) of Latvia in 2005?
Keep it short and to the point. -19.67. What is the difference between the Imports(as % of merchandise exports) in Faeroe Islands in 2003 and the Imports(as % of merchandise exports) in Latvia in 2005?
Your answer should be very brief. 4.15. What is the difference between the Imports(as % of merchandise exports) of Argentina in 2004 and the Imports(as % of merchandise exports) of Belize in 2005?
Provide a succinct answer. 27.04. What is the difference between the Imports(as % of merchandise exports) of Argentina in 2004 and the Imports(as % of merchandise exports) of Faeroe Islands in 2005?
Ensure brevity in your answer.  21.29. What is the difference between the Imports(as % of merchandise exports) of Argentina in 2004 and the Imports(as % of merchandise exports) of Latvia in 2005?
Provide a succinct answer. 20.44. What is the difference between the Imports(as % of merchandise exports) in Belize in 2004 and the Imports(as % of merchandise exports) in Faeroe Islands in 2005?
Your response must be concise. -20.05. What is the difference between the Imports(as % of merchandise exports) in Belize in 2004 and the Imports(as % of merchandise exports) in Latvia in 2005?
Make the answer very short. -20.91. What is the difference between the Imports(as % of merchandise exports) of Faeroe Islands in 2004 and the Imports(as % of merchandise exports) of Latvia in 2005?
Your answer should be compact. -5.19. What is the average Imports(as % of merchandise exports) in Argentina per year?
Your answer should be very brief. 86.79. What is the average Imports(as % of merchandise exports) in Belize per year?
Your answer should be compact. 51.24. What is the average Imports(as % of merchandise exports) of Faeroe Islands per year?
Ensure brevity in your answer.  64.51. What is the average Imports(as % of merchandise exports) in Latvia per year?
Your answer should be very brief. 72. In the year 1998, what is the difference between the Imports(as % of merchandise exports) of Argentina and Imports(as % of merchandise exports) of Belize?
Offer a very short reply. 20.88. In the year 1998, what is the difference between the Imports(as % of merchandise exports) of Argentina and Imports(as % of merchandise exports) of Faeroe Islands?
Give a very brief answer. 28.19. In the year 1998, what is the difference between the Imports(as % of merchandise exports) of Argentina and Imports(as % of merchandise exports) of Latvia?
Offer a very short reply. 15.15. In the year 1998, what is the difference between the Imports(as % of merchandise exports) of Belize and Imports(as % of merchandise exports) of Faeroe Islands?
Offer a very short reply. 7.31. In the year 1998, what is the difference between the Imports(as % of merchandise exports) of Belize and Imports(as % of merchandise exports) of Latvia?
Offer a terse response. -5.73. In the year 1998, what is the difference between the Imports(as % of merchandise exports) of Faeroe Islands and Imports(as % of merchandise exports) of Latvia?
Offer a very short reply. -13.04. In the year 1999, what is the difference between the Imports(as % of merchandise exports) of Argentina and Imports(as % of merchandise exports) of Belize?
Offer a very short reply. 63.07. In the year 1999, what is the difference between the Imports(as % of merchandise exports) in Argentina and Imports(as % of merchandise exports) in Faeroe Islands?
Provide a succinct answer. 22.82. In the year 1999, what is the difference between the Imports(as % of merchandise exports) in Argentina and Imports(as % of merchandise exports) in Latvia?
Your response must be concise. 15.48. In the year 1999, what is the difference between the Imports(as % of merchandise exports) in Belize and Imports(as % of merchandise exports) in Faeroe Islands?
Provide a short and direct response. -40.25. In the year 1999, what is the difference between the Imports(as % of merchandise exports) in Belize and Imports(as % of merchandise exports) in Latvia?
Give a very brief answer. -47.59. In the year 1999, what is the difference between the Imports(as % of merchandise exports) of Faeroe Islands and Imports(as % of merchandise exports) of Latvia?
Offer a very short reply. -7.34. In the year 2000, what is the difference between the Imports(as % of merchandise exports) of Argentina and Imports(as % of merchandise exports) of Belize?
Offer a very short reply. 19.58. In the year 2000, what is the difference between the Imports(as % of merchandise exports) in Argentina and Imports(as % of merchandise exports) in Faeroe Islands?
Give a very brief answer. 21.51. In the year 2000, what is the difference between the Imports(as % of merchandise exports) of Argentina and Imports(as % of merchandise exports) of Latvia?
Make the answer very short. 15.49. In the year 2000, what is the difference between the Imports(as % of merchandise exports) of Belize and Imports(as % of merchandise exports) of Faeroe Islands?
Your answer should be compact. 1.93. In the year 2000, what is the difference between the Imports(as % of merchandise exports) in Belize and Imports(as % of merchandise exports) in Latvia?
Offer a very short reply. -4.09. In the year 2000, what is the difference between the Imports(as % of merchandise exports) of Faeroe Islands and Imports(as % of merchandise exports) of Latvia?
Offer a very short reply. -6.02. In the year 2001, what is the difference between the Imports(as % of merchandise exports) of Argentina and Imports(as % of merchandise exports) of Belize?
Your response must be concise. 37. In the year 2001, what is the difference between the Imports(as % of merchandise exports) of Argentina and Imports(as % of merchandise exports) of Faeroe Islands?
Offer a terse response. 23.78. In the year 2001, what is the difference between the Imports(as % of merchandise exports) of Argentina and Imports(as % of merchandise exports) of Latvia?
Keep it short and to the point. 12.77. In the year 2001, what is the difference between the Imports(as % of merchandise exports) of Belize and Imports(as % of merchandise exports) of Faeroe Islands?
Make the answer very short. -13.23. In the year 2001, what is the difference between the Imports(as % of merchandise exports) of Belize and Imports(as % of merchandise exports) of Latvia?
Provide a short and direct response. -24.23. In the year 2001, what is the difference between the Imports(as % of merchandise exports) in Faeroe Islands and Imports(as % of merchandise exports) in Latvia?
Keep it short and to the point. -11.01. In the year 2002, what is the difference between the Imports(as % of merchandise exports) in Argentina and Imports(as % of merchandise exports) in Belize?
Ensure brevity in your answer.  36.39. In the year 2002, what is the difference between the Imports(as % of merchandise exports) of Argentina and Imports(as % of merchandise exports) of Faeroe Islands?
Your response must be concise. 19.78. In the year 2002, what is the difference between the Imports(as % of merchandise exports) of Argentina and Imports(as % of merchandise exports) of Latvia?
Make the answer very short. 9.96. In the year 2002, what is the difference between the Imports(as % of merchandise exports) in Belize and Imports(as % of merchandise exports) in Faeroe Islands?
Provide a succinct answer. -16.61. In the year 2002, what is the difference between the Imports(as % of merchandise exports) of Belize and Imports(as % of merchandise exports) of Latvia?
Keep it short and to the point. -26.43. In the year 2002, what is the difference between the Imports(as % of merchandise exports) of Faeroe Islands and Imports(as % of merchandise exports) of Latvia?
Offer a terse response. -9.82. In the year 2003, what is the difference between the Imports(as % of merchandise exports) in Argentina and Imports(as % of merchandise exports) in Belize?
Your answer should be very brief. 39.3. In the year 2003, what is the difference between the Imports(as % of merchandise exports) of Argentina and Imports(as % of merchandise exports) of Faeroe Islands?
Keep it short and to the point. 15.48. In the year 2003, what is the difference between the Imports(as % of merchandise exports) in Argentina and Imports(as % of merchandise exports) in Latvia?
Your answer should be compact. 11.97. In the year 2003, what is the difference between the Imports(as % of merchandise exports) in Belize and Imports(as % of merchandise exports) in Faeroe Islands?
Make the answer very short. -23.83. In the year 2003, what is the difference between the Imports(as % of merchandise exports) of Belize and Imports(as % of merchandise exports) of Latvia?
Offer a terse response. -27.33. In the year 2003, what is the difference between the Imports(as % of merchandise exports) of Faeroe Islands and Imports(as % of merchandise exports) of Latvia?
Ensure brevity in your answer.  -3.51. In the year 2004, what is the difference between the Imports(as % of merchandise exports) of Argentina and Imports(as % of merchandise exports) of Belize?
Your response must be concise. 41.34. In the year 2004, what is the difference between the Imports(as % of merchandise exports) of Argentina and Imports(as % of merchandise exports) of Faeroe Islands?
Provide a succinct answer. 25.63. In the year 2004, what is the difference between the Imports(as % of merchandise exports) in Argentina and Imports(as % of merchandise exports) in Latvia?
Provide a short and direct response. 17.26. In the year 2004, what is the difference between the Imports(as % of merchandise exports) of Belize and Imports(as % of merchandise exports) of Faeroe Islands?
Your response must be concise. -15.72. In the year 2004, what is the difference between the Imports(as % of merchandise exports) in Belize and Imports(as % of merchandise exports) in Latvia?
Provide a succinct answer. -24.08. In the year 2004, what is the difference between the Imports(as % of merchandise exports) of Faeroe Islands and Imports(as % of merchandise exports) of Latvia?
Make the answer very short. -8.37. In the year 2005, what is the difference between the Imports(as % of merchandise exports) in Argentina and Imports(as % of merchandise exports) in Belize?
Provide a succinct answer. 26.83. In the year 2005, what is the difference between the Imports(as % of merchandise exports) in Argentina and Imports(as % of merchandise exports) in Faeroe Islands?
Offer a terse response. 21.09. In the year 2005, what is the difference between the Imports(as % of merchandise exports) in Argentina and Imports(as % of merchandise exports) in Latvia?
Offer a very short reply. 20.23. In the year 2005, what is the difference between the Imports(as % of merchandise exports) in Belize and Imports(as % of merchandise exports) in Faeroe Islands?
Provide a succinct answer. -5.74. In the year 2005, what is the difference between the Imports(as % of merchandise exports) in Belize and Imports(as % of merchandise exports) in Latvia?
Keep it short and to the point. -6.6. In the year 2005, what is the difference between the Imports(as % of merchandise exports) in Faeroe Islands and Imports(as % of merchandise exports) in Latvia?
Your response must be concise. -0.86. What is the ratio of the Imports(as % of merchandise exports) in Belize in 1998 to that in 1999?
Provide a succinct answer. 2.64. What is the ratio of the Imports(as % of merchandise exports) of Faeroe Islands in 1998 to that in 1999?
Ensure brevity in your answer.  0.92. What is the ratio of the Imports(as % of merchandise exports) of Latvia in 1998 to that in 1999?
Your answer should be very brief. 1. What is the ratio of the Imports(as % of merchandise exports) in Faeroe Islands in 1998 to that in 2000?
Provide a succinct answer. 0.93. What is the ratio of the Imports(as % of merchandise exports) of Latvia in 1998 to that in 2000?
Provide a succinct answer. 1.03. What is the ratio of the Imports(as % of merchandise exports) in Argentina in 1998 to that in 2001?
Make the answer very short. 1.03. What is the ratio of the Imports(as % of merchandise exports) in Belize in 1998 to that in 2001?
Your answer should be very brief. 1.38. What is the ratio of the Imports(as % of merchandise exports) of Faeroe Islands in 1998 to that in 2001?
Offer a terse response. 0.97. What is the ratio of the Imports(as % of merchandise exports) in Argentina in 1998 to that in 2002?
Make the answer very short. 1.06. What is the ratio of the Imports(as % of merchandise exports) in Belize in 1998 to that in 2002?
Give a very brief answer. 1.43. What is the ratio of the Imports(as % of merchandise exports) of Faeroe Islands in 1998 to that in 2002?
Offer a terse response. 0.95. What is the ratio of the Imports(as % of merchandise exports) of Argentina in 1998 to that in 2003?
Keep it short and to the point. 1.03. What is the ratio of the Imports(as % of merchandise exports) of Belize in 1998 to that in 2003?
Provide a short and direct response. 1.45. What is the ratio of the Imports(as % of merchandise exports) in Faeroe Islands in 1998 to that in 2003?
Keep it short and to the point. 0.86. What is the ratio of the Imports(as % of merchandise exports) of Latvia in 1998 to that in 2003?
Provide a short and direct response. 0.99. What is the ratio of the Imports(as % of merchandise exports) of Argentina in 1998 to that in 2004?
Your response must be concise. 1.02. What is the ratio of the Imports(as % of merchandise exports) in Belize in 1998 to that in 2004?
Offer a very short reply. 1.49. What is the ratio of the Imports(as % of merchandise exports) of Latvia in 1998 to that in 2004?
Provide a succinct answer. 1.06. What is the ratio of the Imports(as % of merchandise exports) in Argentina in 1998 to that in 2005?
Offer a very short reply. 1.02. What is the ratio of the Imports(as % of merchandise exports) in Belize in 1998 to that in 2005?
Ensure brevity in your answer.  1.14. What is the ratio of the Imports(as % of merchandise exports) in Faeroe Islands in 1998 to that in 2005?
Provide a succinct answer. 0.92. What is the ratio of the Imports(as % of merchandise exports) in Latvia in 1998 to that in 2005?
Ensure brevity in your answer.  1.11. What is the ratio of the Imports(as % of merchandise exports) of Argentina in 1999 to that in 2000?
Give a very brief answer. 1.02. What is the ratio of the Imports(as % of merchandise exports) of Belize in 1999 to that in 2000?
Keep it short and to the point. 0.38. What is the ratio of the Imports(as % of merchandise exports) in Faeroe Islands in 1999 to that in 2000?
Offer a terse response. 1.01. What is the ratio of the Imports(as % of merchandise exports) in Latvia in 1999 to that in 2000?
Keep it short and to the point. 1.03. What is the ratio of the Imports(as % of merchandise exports) of Argentina in 1999 to that in 2001?
Give a very brief answer. 1.03. What is the ratio of the Imports(as % of merchandise exports) in Belize in 1999 to that in 2001?
Your answer should be compact. 0.52. What is the ratio of the Imports(as % of merchandise exports) in Faeroe Islands in 1999 to that in 2001?
Keep it short and to the point. 1.06. What is the ratio of the Imports(as % of merchandise exports) in Latvia in 1999 to that in 2001?
Offer a terse response. 1. What is the ratio of the Imports(as % of merchandise exports) in Argentina in 1999 to that in 2002?
Your response must be concise. 1.06. What is the ratio of the Imports(as % of merchandise exports) of Belize in 1999 to that in 2002?
Offer a terse response. 0.54. What is the ratio of the Imports(as % of merchandise exports) of Faeroe Islands in 1999 to that in 2002?
Your response must be concise. 1.03. What is the ratio of the Imports(as % of merchandise exports) of Latvia in 1999 to that in 2002?
Your answer should be very brief. 0.99. What is the ratio of the Imports(as % of merchandise exports) of Argentina in 1999 to that in 2003?
Offer a terse response. 1.03. What is the ratio of the Imports(as % of merchandise exports) of Belize in 1999 to that in 2003?
Your response must be concise. 0.55. What is the ratio of the Imports(as % of merchandise exports) in Faeroe Islands in 1999 to that in 2003?
Ensure brevity in your answer.  0.93. What is the ratio of the Imports(as % of merchandise exports) in Latvia in 1999 to that in 2003?
Provide a succinct answer. 0.99. What is the ratio of the Imports(as % of merchandise exports) of Argentina in 1999 to that in 2004?
Your answer should be very brief. 1.02. What is the ratio of the Imports(as % of merchandise exports) of Belize in 1999 to that in 2004?
Give a very brief answer. 0.56. What is the ratio of the Imports(as % of merchandise exports) in Latvia in 1999 to that in 2004?
Keep it short and to the point. 1.05. What is the ratio of the Imports(as % of merchandise exports) of Argentina in 1999 to that in 2005?
Keep it short and to the point. 1.02. What is the ratio of the Imports(as % of merchandise exports) of Belize in 1999 to that in 2005?
Offer a very short reply. 0.43. What is the ratio of the Imports(as % of merchandise exports) in Faeroe Islands in 1999 to that in 2005?
Provide a succinct answer. 1.01. What is the ratio of the Imports(as % of merchandise exports) in Latvia in 1999 to that in 2005?
Your response must be concise. 1.1. What is the ratio of the Imports(as % of merchandise exports) in Argentina in 2000 to that in 2001?
Make the answer very short. 1.01. What is the ratio of the Imports(as % of merchandise exports) in Belize in 2000 to that in 2001?
Provide a succinct answer. 1.37. What is the ratio of the Imports(as % of merchandise exports) of Faeroe Islands in 2000 to that in 2001?
Your answer should be very brief. 1.05. What is the ratio of the Imports(as % of merchandise exports) of Argentina in 2000 to that in 2002?
Make the answer very short. 1.04. What is the ratio of the Imports(as % of merchandise exports) in Belize in 2000 to that in 2002?
Offer a terse response. 1.42. What is the ratio of the Imports(as % of merchandise exports) in Faeroe Islands in 2000 to that in 2002?
Ensure brevity in your answer.  1.02. What is the ratio of the Imports(as % of merchandise exports) in Argentina in 2000 to that in 2003?
Provide a short and direct response. 1.01. What is the ratio of the Imports(as % of merchandise exports) of Belize in 2000 to that in 2003?
Your answer should be very brief. 1.44. What is the ratio of the Imports(as % of merchandise exports) of Faeroe Islands in 2000 to that in 2003?
Keep it short and to the point. 0.93. What is the ratio of the Imports(as % of merchandise exports) in Latvia in 2000 to that in 2003?
Provide a succinct answer. 0.96. What is the ratio of the Imports(as % of merchandise exports) of Argentina in 2000 to that in 2004?
Provide a short and direct response. 1. What is the ratio of the Imports(as % of merchandise exports) in Belize in 2000 to that in 2004?
Offer a very short reply. 1.48. What is the ratio of the Imports(as % of merchandise exports) in Faeroe Islands in 2000 to that in 2004?
Your response must be concise. 1.07. What is the ratio of the Imports(as % of merchandise exports) of Latvia in 2000 to that in 2004?
Your answer should be very brief. 1.03. What is the ratio of the Imports(as % of merchandise exports) of Argentina in 2000 to that in 2005?
Offer a very short reply. 1. What is the ratio of the Imports(as % of merchandise exports) in Belize in 2000 to that in 2005?
Provide a succinct answer. 1.13. What is the ratio of the Imports(as % of merchandise exports) in Latvia in 2000 to that in 2005?
Keep it short and to the point. 1.08. What is the ratio of the Imports(as % of merchandise exports) of Argentina in 2001 to that in 2002?
Make the answer very short. 1.03. What is the ratio of the Imports(as % of merchandise exports) of Belize in 2001 to that in 2002?
Offer a terse response. 1.04. What is the ratio of the Imports(as % of merchandise exports) in Faeroe Islands in 2001 to that in 2002?
Your response must be concise. 0.97. What is the ratio of the Imports(as % of merchandise exports) in Latvia in 2001 to that in 2002?
Ensure brevity in your answer.  0.99. What is the ratio of the Imports(as % of merchandise exports) of Belize in 2001 to that in 2003?
Offer a very short reply. 1.05. What is the ratio of the Imports(as % of merchandise exports) in Faeroe Islands in 2001 to that in 2003?
Your response must be concise. 0.88. What is the ratio of the Imports(as % of merchandise exports) of Belize in 2001 to that in 2004?
Give a very brief answer. 1.08. What is the ratio of the Imports(as % of merchandise exports) of Faeroe Islands in 2001 to that in 2004?
Your answer should be compact. 1.02. What is the ratio of the Imports(as % of merchandise exports) in Latvia in 2001 to that in 2004?
Offer a very short reply. 1.06. What is the ratio of the Imports(as % of merchandise exports) of Belize in 2001 to that in 2005?
Offer a terse response. 0.82. What is the ratio of the Imports(as % of merchandise exports) of Faeroe Islands in 2001 to that in 2005?
Your answer should be very brief. 0.95. What is the ratio of the Imports(as % of merchandise exports) in Latvia in 2001 to that in 2005?
Ensure brevity in your answer.  1.11. What is the ratio of the Imports(as % of merchandise exports) in Argentina in 2002 to that in 2003?
Offer a very short reply. 0.97. What is the ratio of the Imports(as % of merchandise exports) of Belize in 2002 to that in 2003?
Keep it short and to the point. 1.02. What is the ratio of the Imports(as % of merchandise exports) in Faeroe Islands in 2002 to that in 2003?
Ensure brevity in your answer.  0.91. What is the ratio of the Imports(as % of merchandise exports) of Latvia in 2002 to that in 2003?
Give a very brief answer. 1. What is the ratio of the Imports(as % of merchandise exports) of Argentina in 2002 to that in 2004?
Provide a succinct answer. 0.97. What is the ratio of the Imports(as % of merchandise exports) in Belize in 2002 to that in 2004?
Offer a terse response. 1.04. What is the ratio of the Imports(as % of merchandise exports) in Faeroe Islands in 2002 to that in 2004?
Keep it short and to the point. 1.05. What is the ratio of the Imports(as % of merchandise exports) in Latvia in 2002 to that in 2004?
Offer a terse response. 1.06. What is the ratio of the Imports(as % of merchandise exports) in Argentina in 2002 to that in 2005?
Give a very brief answer. 0.97. What is the ratio of the Imports(as % of merchandise exports) in Belize in 2002 to that in 2005?
Your answer should be very brief. 0.79. What is the ratio of the Imports(as % of merchandise exports) of Faeroe Islands in 2002 to that in 2005?
Make the answer very short. 0.98. What is the ratio of the Imports(as % of merchandise exports) in Latvia in 2002 to that in 2005?
Your response must be concise. 1.11. What is the ratio of the Imports(as % of merchandise exports) of Belize in 2003 to that in 2004?
Offer a terse response. 1.03. What is the ratio of the Imports(as % of merchandise exports) of Faeroe Islands in 2003 to that in 2004?
Offer a very short reply. 1.15. What is the ratio of the Imports(as % of merchandise exports) of Latvia in 2003 to that in 2004?
Give a very brief answer. 1.06. What is the ratio of the Imports(as % of merchandise exports) of Belize in 2003 to that in 2005?
Provide a short and direct response. 0.78. What is the ratio of the Imports(as % of merchandise exports) of Faeroe Islands in 2003 to that in 2005?
Make the answer very short. 1.08. What is the ratio of the Imports(as % of merchandise exports) in Latvia in 2003 to that in 2005?
Give a very brief answer. 1.12. What is the ratio of the Imports(as % of merchandise exports) of Argentina in 2004 to that in 2005?
Ensure brevity in your answer.  1. What is the ratio of the Imports(as % of merchandise exports) of Belize in 2004 to that in 2005?
Your answer should be compact. 0.76. What is the ratio of the Imports(as % of merchandise exports) in Faeroe Islands in 2004 to that in 2005?
Provide a short and direct response. 0.93. What is the ratio of the Imports(as % of merchandise exports) in Latvia in 2004 to that in 2005?
Your response must be concise. 1.05. What is the difference between the highest and the second highest Imports(as % of merchandise exports) of Argentina?
Offer a terse response. 0.02. What is the difference between the highest and the second highest Imports(as % of merchandise exports) of Belize?
Your answer should be very brief. 0.52. What is the difference between the highest and the second highest Imports(as % of merchandise exports) of Faeroe Islands?
Ensure brevity in your answer.  4.63. What is the difference between the highest and the second highest Imports(as % of merchandise exports) in Latvia?
Ensure brevity in your answer.  0.17. What is the difference between the highest and the lowest Imports(as % of merchandise exports) of Argentina?
Keep it short and to the point. 4.91. What is the difference between the highest and the lowest Imports(as % of merchandise exports) in Belize?
Your response must be concise. 42.21. What is the difference between the highest and the lowest Imports(as % of merchandise exports) in Faeroe Islands?
Provide a short and direct response. 9.98. What is the difference between the highest and the lowest Imports(as % of merchandise exports) of Latvia?
Provide a succinct answer. 7.66. 